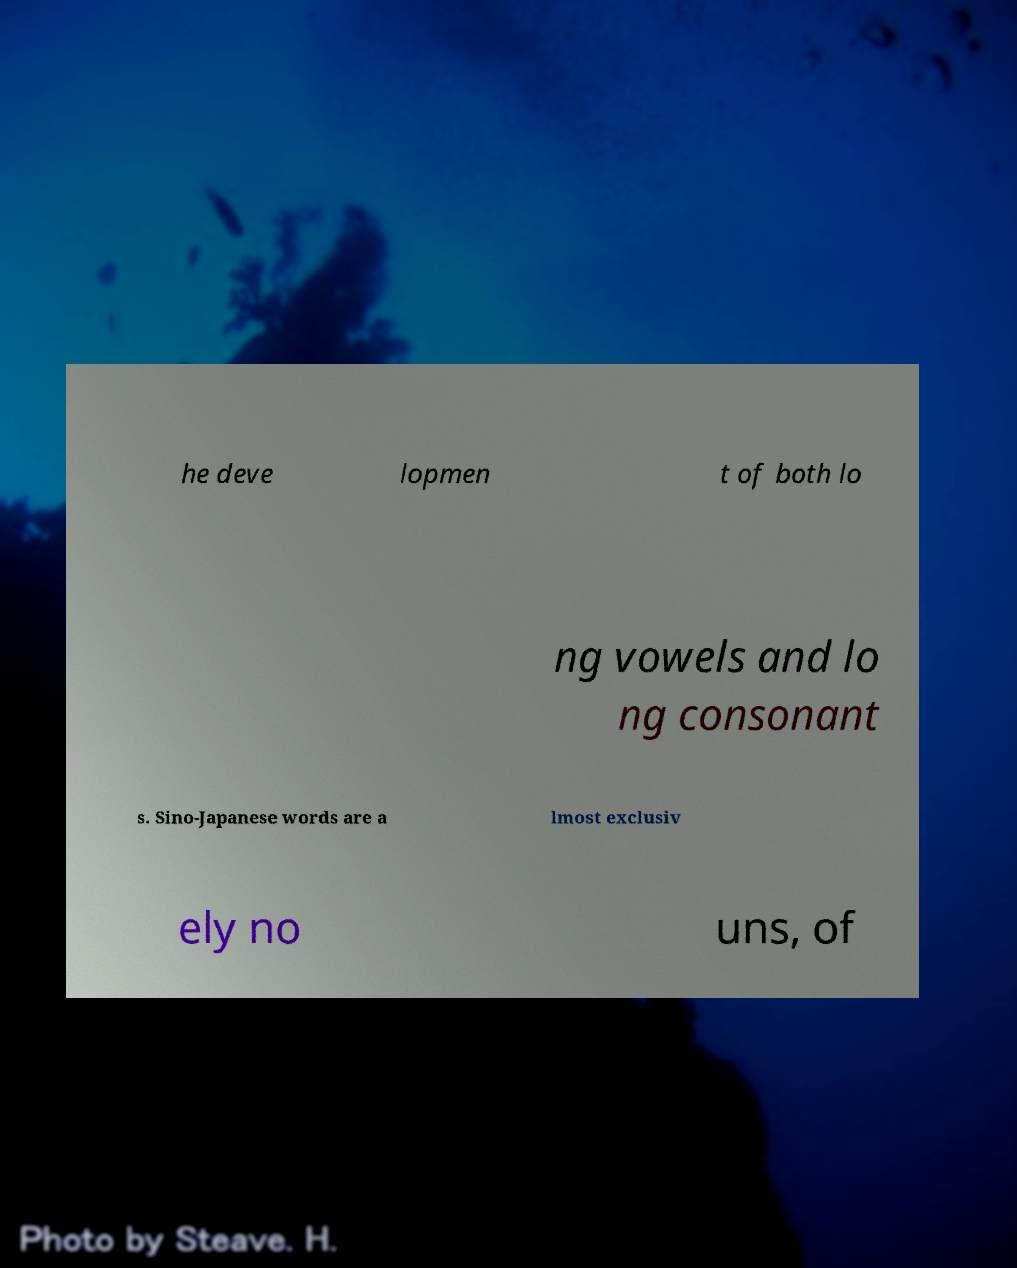Please identify and transcribe the text found in this image. he deve lopmen t of both lo ng vowels and lo ng consonant s. Sino-Japanese words are a lmost exclusiv ely no uns, of 